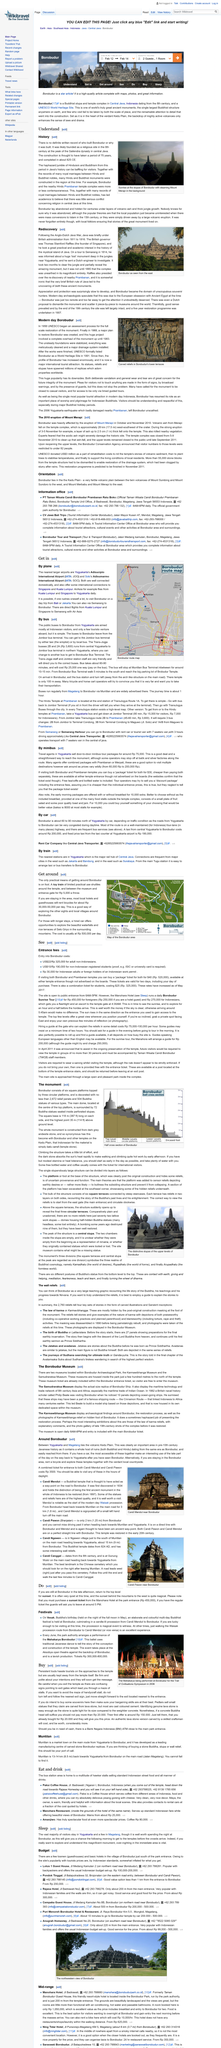Indicate a few pertinent items in this graphic. During the 8th century in Java, the primary religions present were Hinduism and Buddhism. Borobudur was completed around 825 CE. The construction of Borobudur took 75 years to complete. 